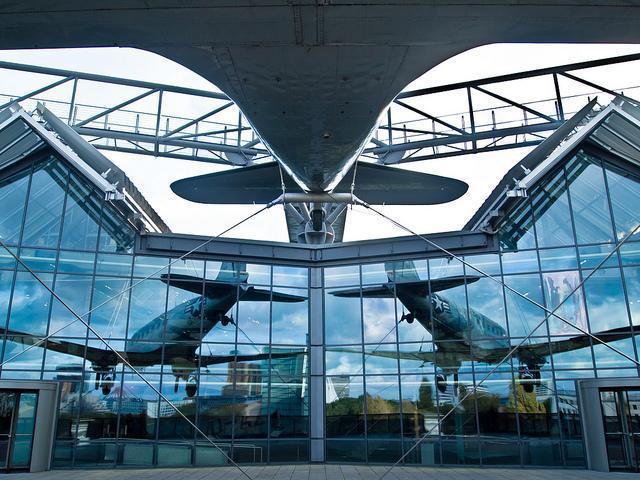How many planes are shown?
Give a very brief answer. 3. How many airplanes are there?
Give a very brief answer. 3. 